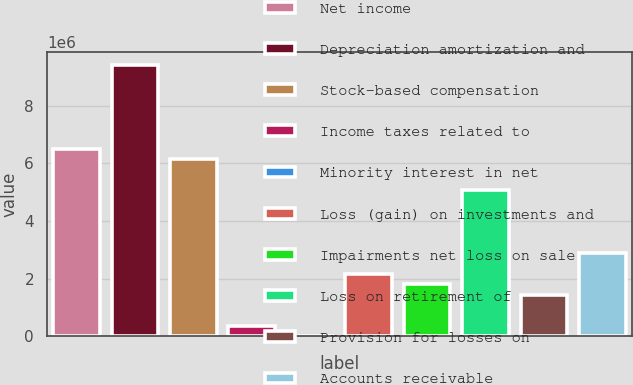<chart> <loc_0><loc_0><loc_500><loc_500><bar_chart><fcel>Net income<fcel>Depreciation amortization and<fcel>Stock-based compensation<fcel>Income taxes related to<fcel>Minority interest in net<fcel>Loss (gain) on investments and<fcel>Impairments net loss on sale<fcel>Loss on retirement of<fcel>Provision for losses on<fcel>Accounts receivable<nl><fcel>6.50176e+06<fcel>9.39128e+06<fcel>6.14057e+06<fcel>361528<fcel>338<fcel>2.16748e+06<fcel>1.80629e+06<fcel>5.057e+06<fcel>1.4451e+06<fcel>2.88986e+06<nl></chart> 